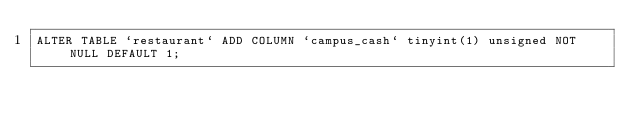<code> <loc_0><loc_0><loc_500><loc_500><_SQL_>ALTER TABLE `restaurant` ADD COLUMN `campus_cash` tinyint(1) unsigned NOT NULL DEFAULT 1;</code> 